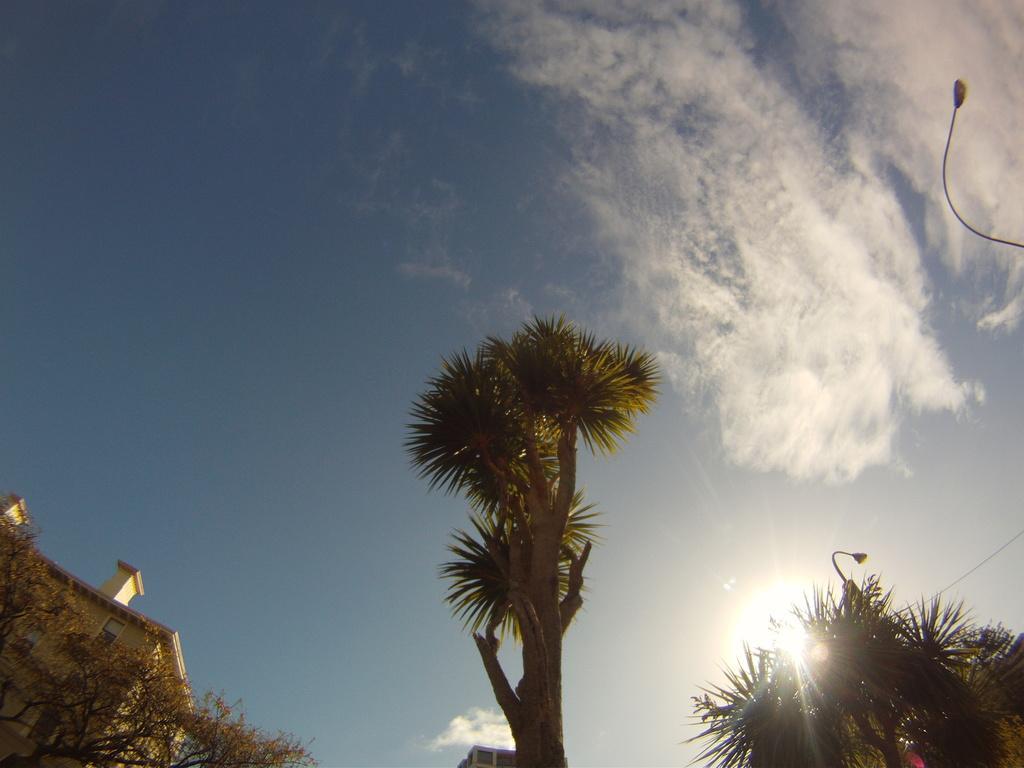How would you summarize this image in a sentence or two? In this image we can see trees, building, the sun and the blue color sky with clouds in the background. 